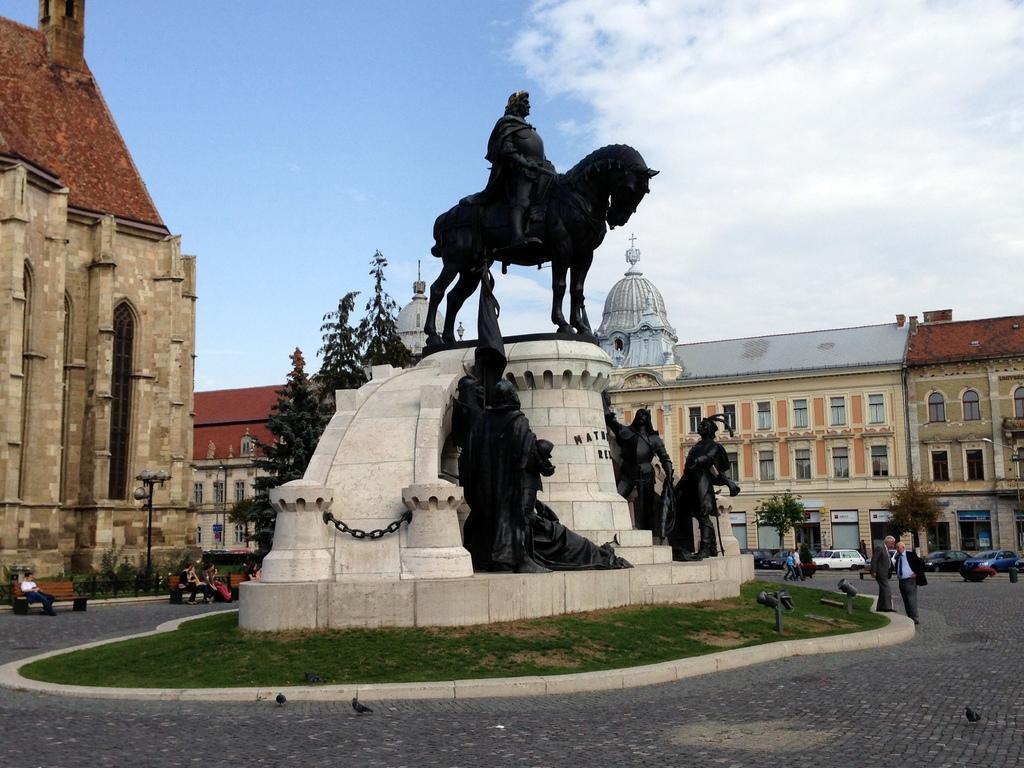In one or two sentences, can you explain what this image depicts? In the image we can see there are many buildings and the windows of the buildings. We can even see there are sculptures and vehicles. We can even see there are people standing, some of them are walking and sitting, they are wearing clothes. Here we can see grass, benches, poles, trees, footpath and the cloudy sky. 